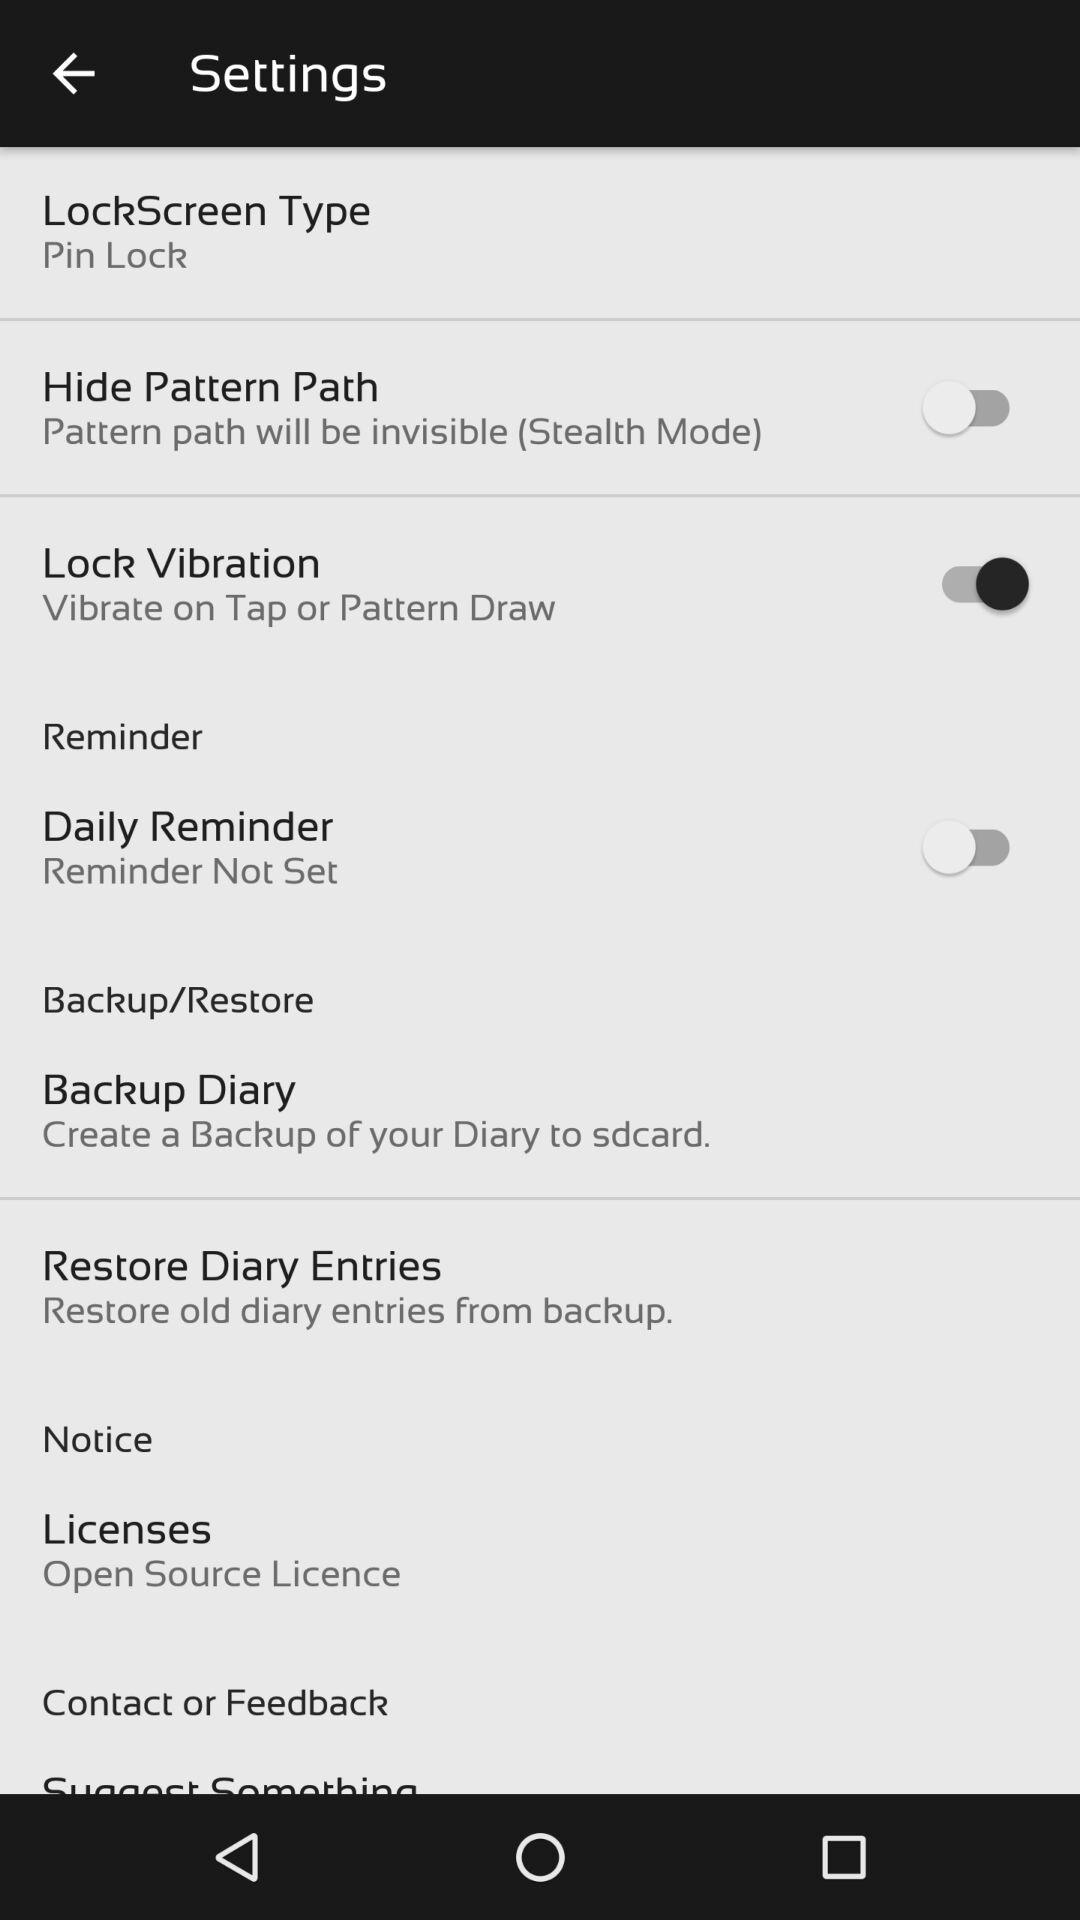Is the daily reminder set? The daily reminder is not set. 